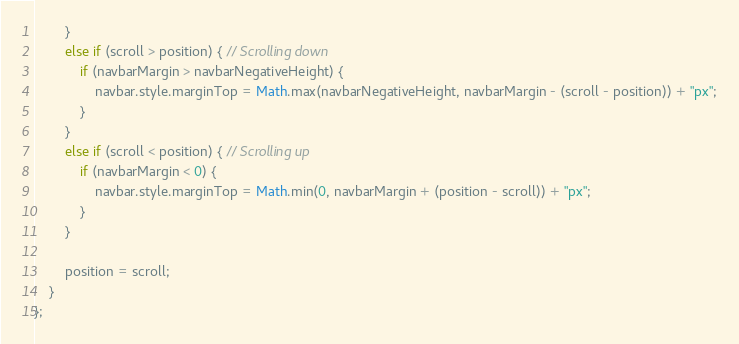Convert code to text. <code><loc_0><loc_0><loc_500><loc_500><_JavaScript_>        }
        else if (scroll > position) { // Scrolling down  
            if (navbarMargin > navbarNegativeHeight) {
                navbar.style.marginTop = Math.max(navbarNegativeHeight, navbarMargin - (scroll - position)) + "px";
            } 
        }
        else if (scroll < position) { // Scrolling up
            if (navbarMargin < 0) {
                navbar.style.marginTop = Math.min(0, navbarMargin + (position - scroll)) + "px";
            }
        }
        
        position = scroll;
    }
};</code> 